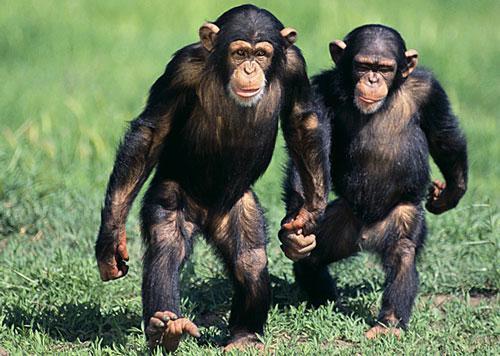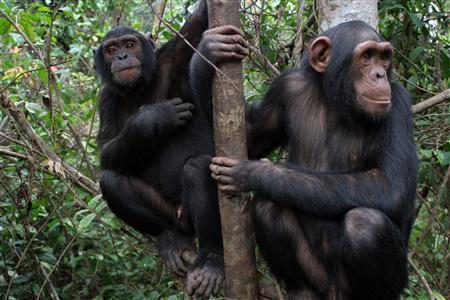The first image is the image on the left, the second image is the image on the right. For the images shown, is this caption "The chimp on the left has both arms extended to grasp the chimp on the right in an image." true? Answer yes or no. No. The first image is the image on the left, the second image is the image on the right. Assess this claim about the two images: "Each image has two primates in the wild.". Correct or not? Answer yes or no. Yes. 